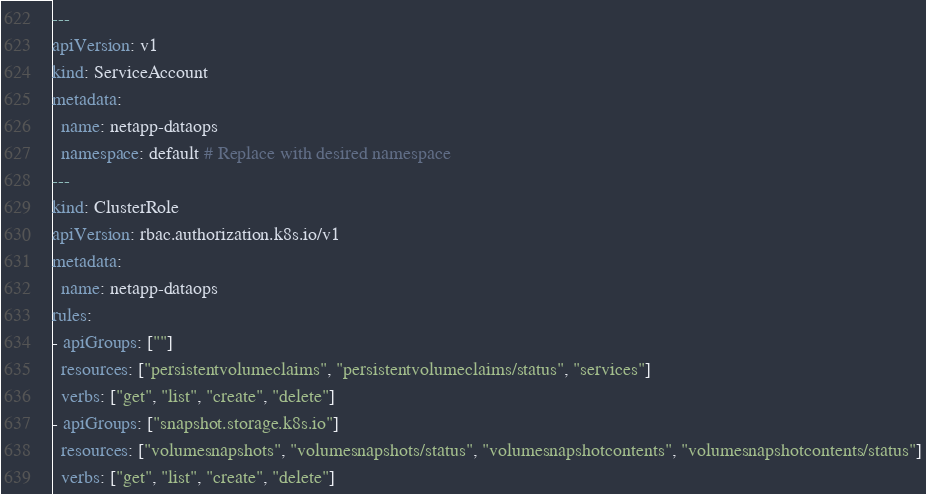Convert code to text. <code><loc_0><loc_0><loc_500><loc_500><_YAML_>---
apiVersion: v1
kind: ServiceAccount
metadata:
  name: netapp-dataops
  namespace: default # Replace with desired namespace
---
kind: ClusterRole
apiVersion: rbac.authorization.k8s.io/v1
metadata:
  name: netapp-dataops
rules:
- apiGroups: [""]
  resources: ["persistentvolumeclaims", "persistentvolumeclaims/status", "services"]
  verbs: ["get", "list", "create", "delete"]
- apiGroups: ["snapshot.storage.k8s.io"]
  resources: ["volumesnapshots", "volumesnapshots/status", "volumesnapshotcontents", "volumesnapshotcontents/status"]
  verbs: ["get", "list", "create", "delete"]</code> 